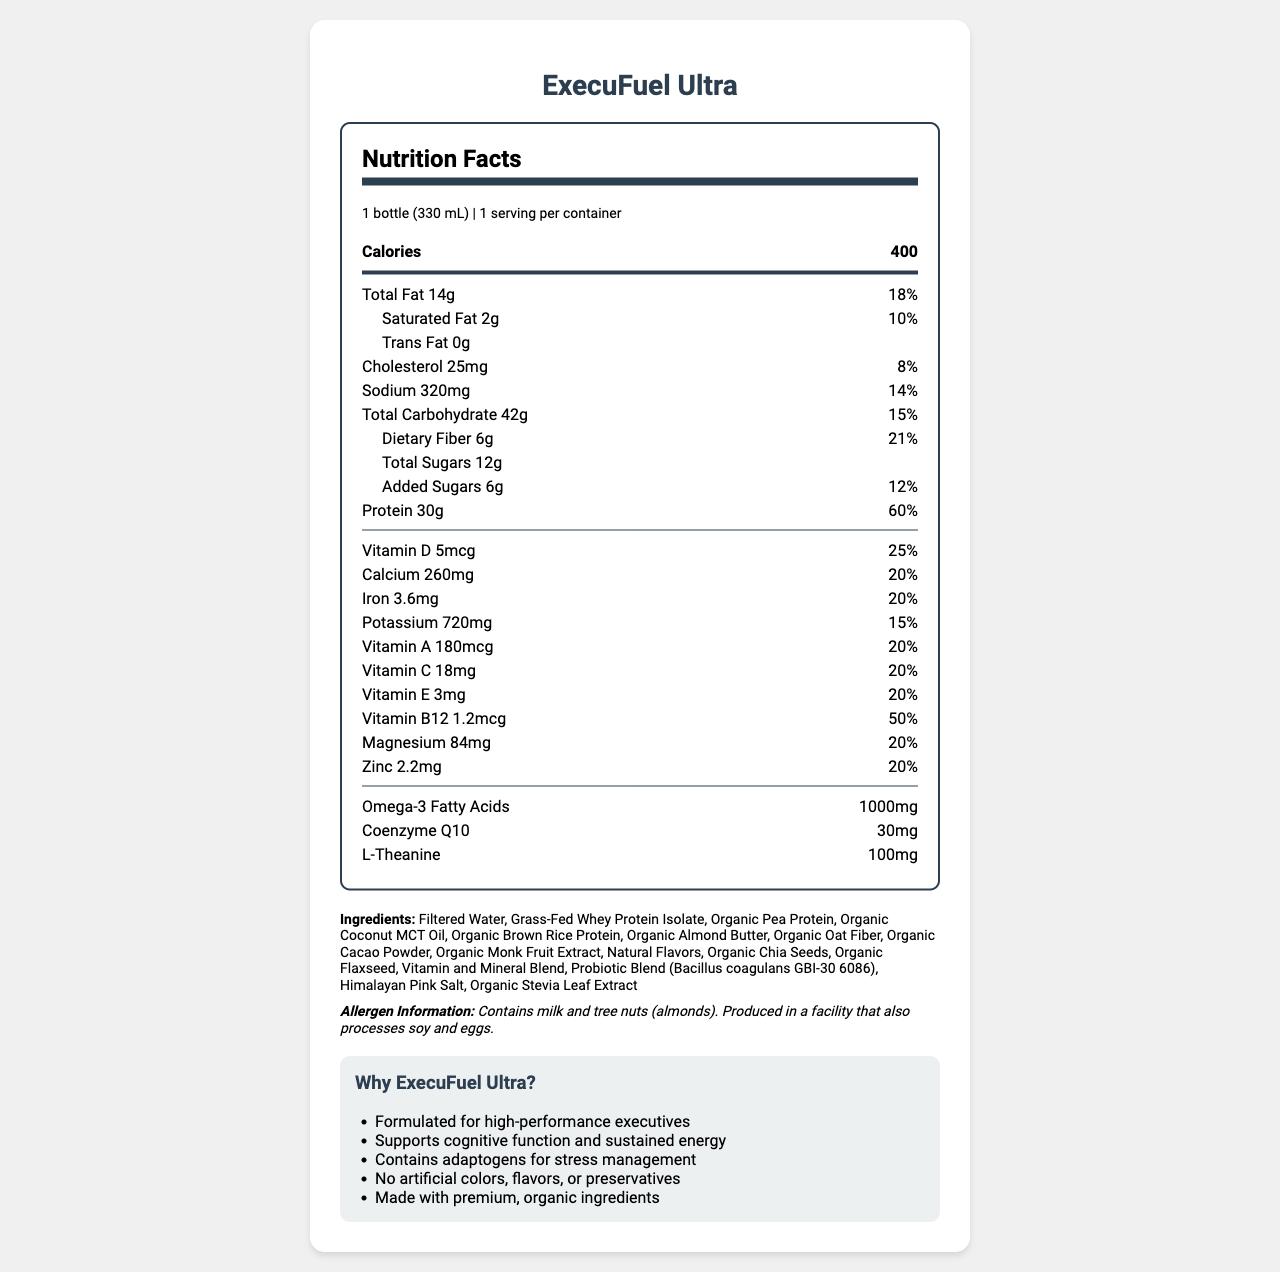what is the product name? The product name is listed at the top of the document.
Answer: ExecuFuel Ultra what is the serving size? The serving size is stated in the serving information section.
Answer: 1 bottle (330 mL) how many calories are in one serving? The number of calories is prominently displayed in the nutrition facts section.
Answer: 400 how much protein does one serving contain? The amount of protein is listed in the nutrition facts section under "Protein".
Answer: 30 g what percentage of the Daily Value is the dietary fiber? The dietary fiber Daily Value percentage is listed in the nutrition facts section.
Answer: 21% which of the following is an ingredient in ExecuFuel Ultra? A. High Fructose Corn Syrup B. Organic Almond Butter C. Artificial Sweeteners D. Soy Protein Organic Almond Butter is listed in the ingredients section. The other options are not listed.
Answer: B how much Omega-3 fatty acids are in one serving? A. 500 mg B. 1000 mg C. 1500 mg D. 2000 mg The nutrition facts section lists 1000 mg of Omega-3 Fatty Acids per serving.
Answer: B is ExecuFuel Ultra free from artificial colors, flavors, or preservatives? The Unique Selling Proposition (USP) section mentions that there are no artificial colors, flavors, or preservatives.
Answer: Yes does ExecuFuel Ultra contain any allergens? The allergen information section states that the product contains milk and tree nuts (almonds) and is produced in a facility that processes soy and eggs.
Answer: Yes which vitamins are present in ExecuFuel Ultra? The nutrition facts section lists vitamins A, C, D, E, and B12, along with their amounts and Daily Values.
Answer: Vitamins A, C, D, E, B12 how long can the product be consumed after opening if kept refrigerated? The storage instructions section states that the product should be consumed within 3 days of opening.
Answer: 3 days summarize the key features and nutritional information of ExecuFuel Ultra in 2-3 sentences. ExecuFuel Ultra targets high-performance professionals with its nutrient-dense profile, focusing on cognitive function, energy, and purity. The nutritional content is highlighted by high protein, essential vitamins, and minerals, while the formulation ensures no artificial additives and includes organic ingredients.
Answer: ExecuFuel Ultra is a high-performance meal replacement shake designed for executives, offering 400 calories per serving with 30 g of protein and a range of essential vitamins and minerals. It supports cognitive function and sustained energy without artificial colors, flavors, or preservatives. The shake contains premium, organic ingredients and is allergen-aware. what is the source of protein in ExecuFuel Ultra? These protein sources are listed in the ingredients section.
Answer: Grass-Fed Whey Protein Isolate, Organic Pea Protein, Organic Brown Rice Protein how much cholesterol is there per serving, and what percent of the Daily Value does it represent? The nutrition facts section states that there are 25 mg of cholesterol per serving, representing 8% of the Daily Value.
Answer: 25 mg, 8% does ExecuFuel Ultra contain any adaptogens? The Unique Selling Proposition (USP) section states that the product contains adaptogens for stress management.
Answer: Yes what is the total amount of sugar in each serving? The total sugars per serving is listed in the nutrition facts section as 12 g.
Answer: 12 g are the vitamins and minerals in ExecuFuel Ultra from natural sources? The document does not specify whether the vitamins and minerals are from natural sources or synthetically derived.
Answer: Not enough information 